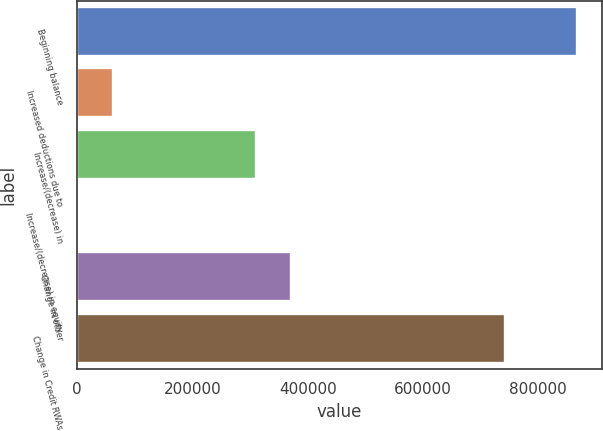Convert chart to OTSL. <chart><loc_0><loc_0><loc_500><loc_500><bar_chart><fcel>Beginning balance<fcel>Increased deductions due to<fcel>Increase/(decrease) in<fcel>Increase/(decrease) in equity<fcel>Change in other<fcel>Change in Credit RWAs<nl><fcel>866850<fcel>62039.5<fcel>309674<fcel>131<fcel>371582<fcel>743033<nl></chart> 